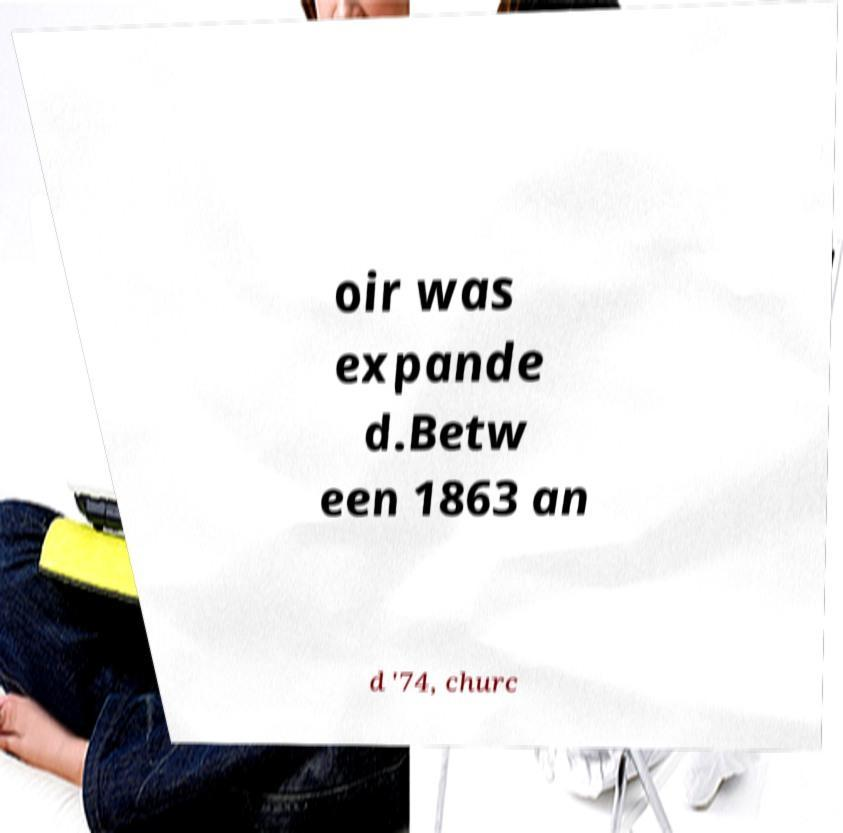Please read and relay the text visible in this image. What does it say? oir was expande d.Betw een 1863 an d '74, churc 